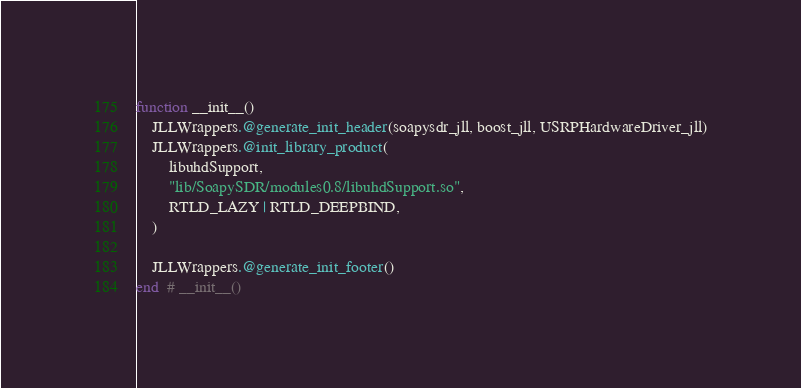<code> <loc_0><loc_0><loc_500><loc_500><_Julia_>function __init__()
    JLLWrappers.@generate_init_header(soapysdr_jll, boost_jll, USRPHardwareDriver_jll)
    JLLWrappers.@init_library_product(
        libuhdSupport,
        "lib/SoapySDR/modules0.8/libuhdSupport.so",
        RTLD_LAZY | RTLD_DEEPBIND,
    )

    JLLWrappers.@generate_init_footer()
end  # __init__()
</code> 